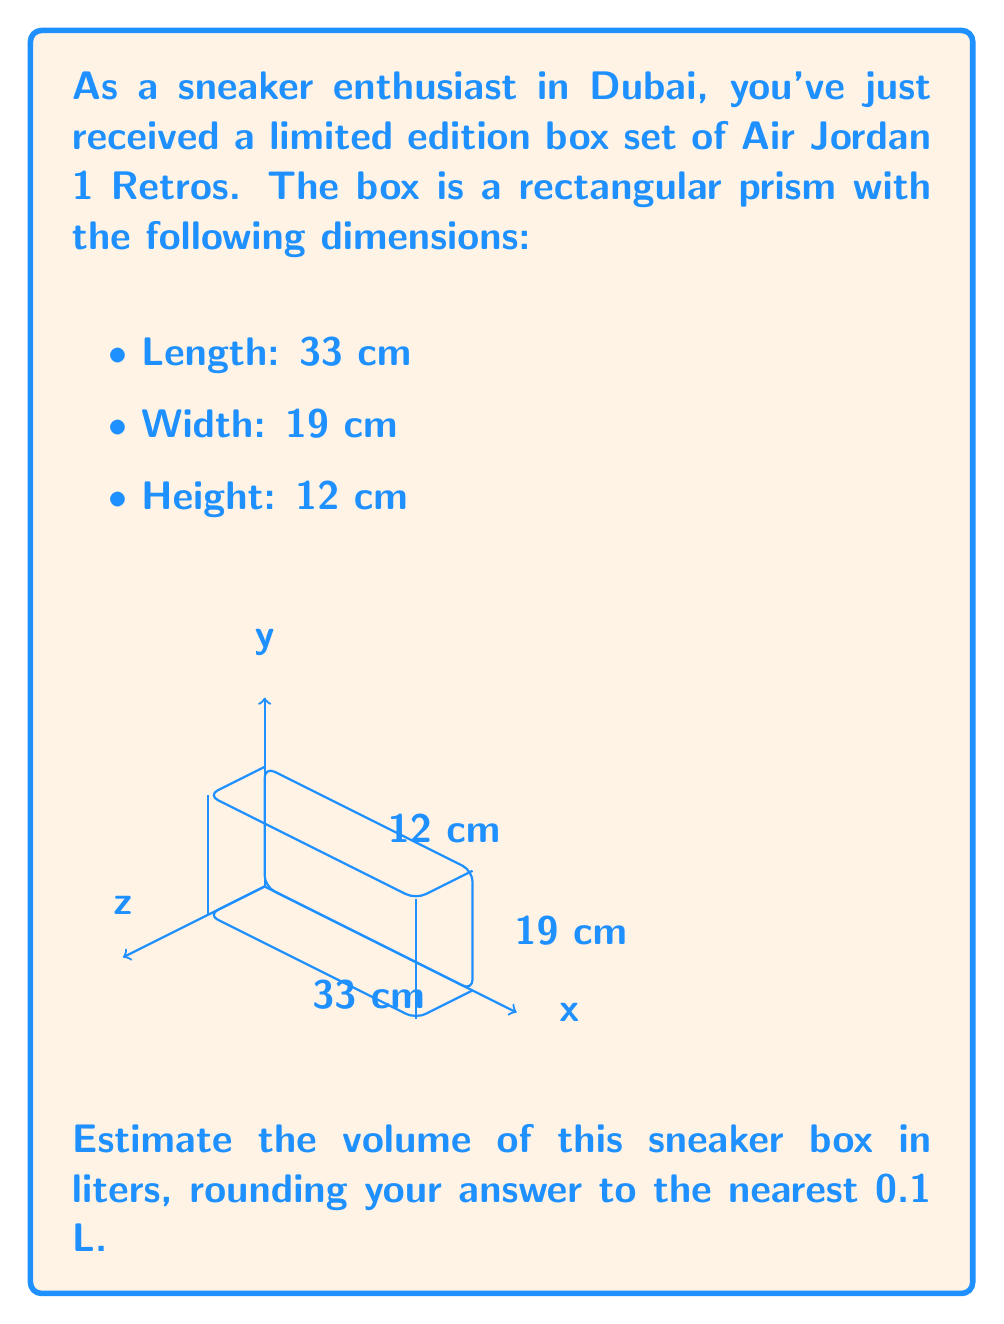Can you solve this math problem? To solve this problem, we'll follow these steps:

1) The volume of a rectangular prism is given by the formula:
   $$V = l \times w \times h$$
   where $V$ is volume, $l$ is length, $w$ is width, and $h$ is height.

2) Substituting the given dimensions:
   $$V = 33 \text{ cm} \times 19 \text{ cm} \times 12 \text{ cm}$$

3) Multiplying these numbers:
   $$V = 7,524 \text{ cm}^3$$

4) To convert cubic centimeters to liters, we use the conversion:
   $$1 \text{ L} = 1000 \text{ cm}^3$$

5) Dividing our result by 1000:
   $$V = 7,524 \div 1000 = 7.524 \text{ L}$$

6) Rounding to the nearest 0.1 L:
   $$V \approx 7.5 \text{ L}$$

Therefore, the estimated volume of the sneaker box is approximately 7.5 liters.
Answer: 7.5 L 